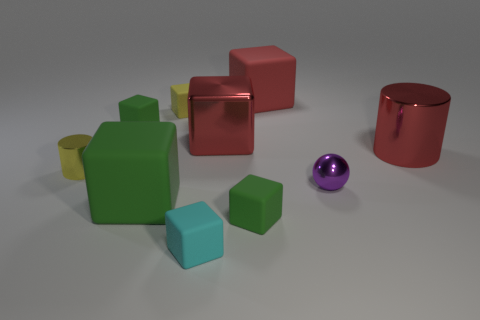Subtract all green blocks. How many were subtracted if there are1green blocks left? 2 Subtract all tiny cyan cubes. How many cubes are left? 6 Subtract all green blocks. How many blocks are left? 4 Subtract all green balls. How many green cubes are left? 3 Subtract 1 spheres. How many spheres are left? 0 Subtract all cubes. How many objects are left? 3 Add 3 green cubes. How many green cubes exist? 6 Subtract 0 gray balls. How many objects are left? 10 Subtract all yellow cubes. Subtract all gray balls. How many cubes are left? 6 Subtract all large blocks. Subtract all tiny rubber cubes. How many objects are left? 3 